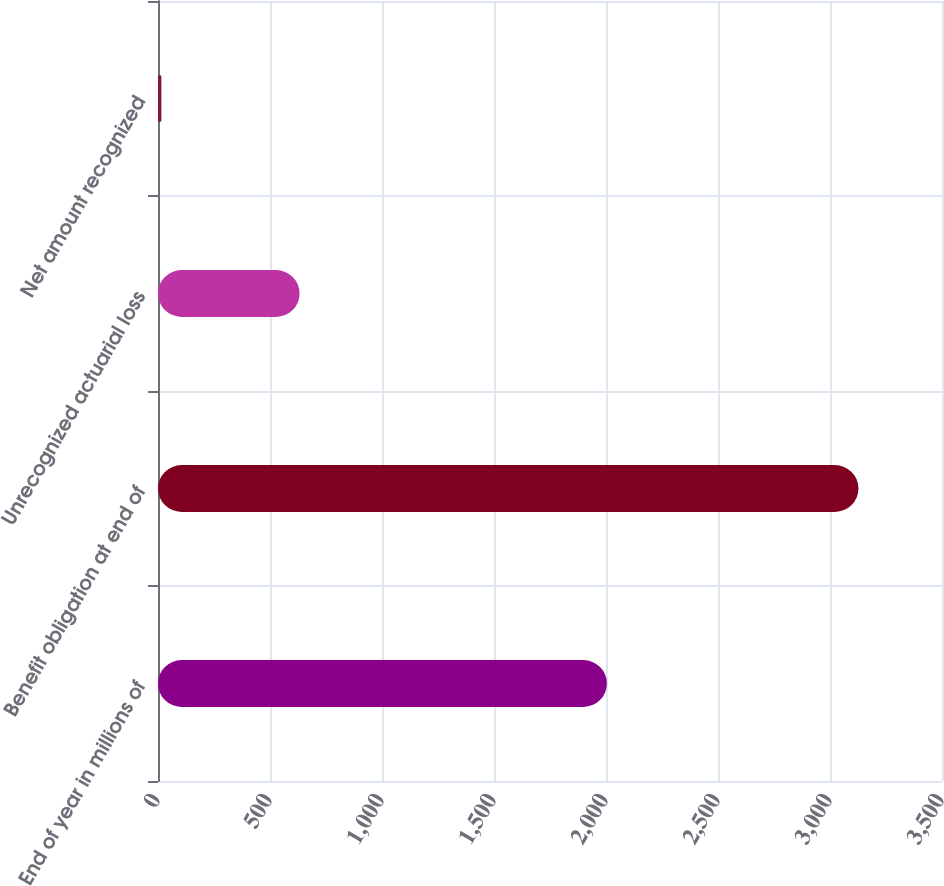<chart> <loc_0><loc_0><loc_500><loc_500><bar_chart><fcel>End of year in millions of<fcel>Benefit obligation at end of<fcel>Unrecognized actuarial loss<fcel>Net amount recognized<nl><fcel>2004<fcel>3127<fcel>632<fcel>15<nl></chart> 